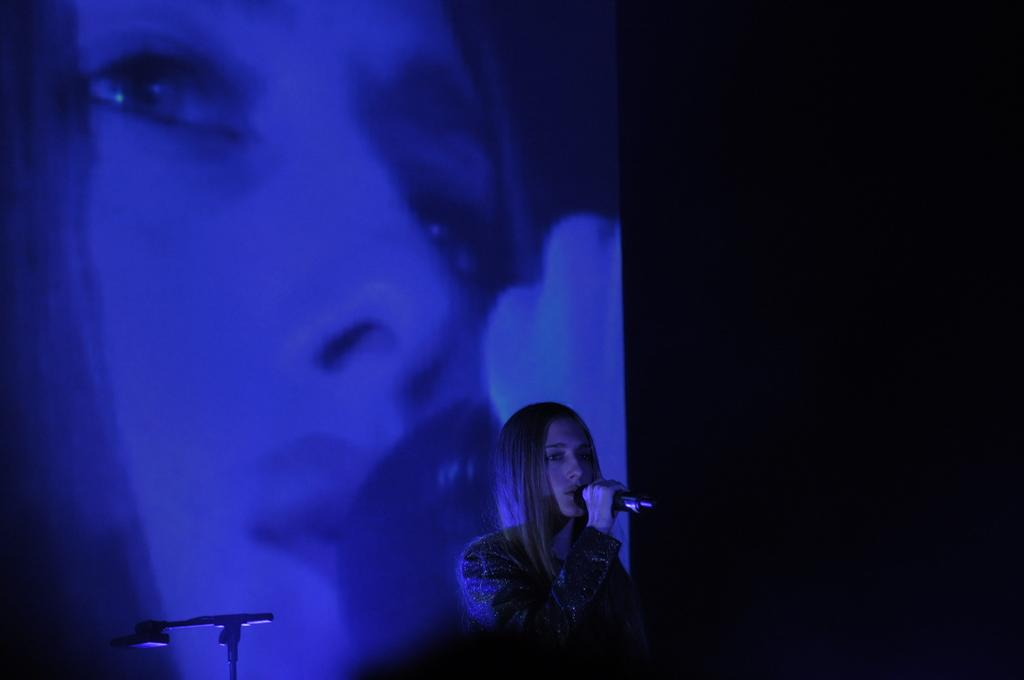What is the lady in the image holding? The lady is holding a microphone in the image. What can be seen in the background of the image? There is a screen in the background of the image. What is displayed on the screen? The screen displays a picture of a lady. What type of steel is used to construct the microphone in the image? There is no information about the material used to construct the microphone in the image, and therefore we cannot determine if steel is used. 